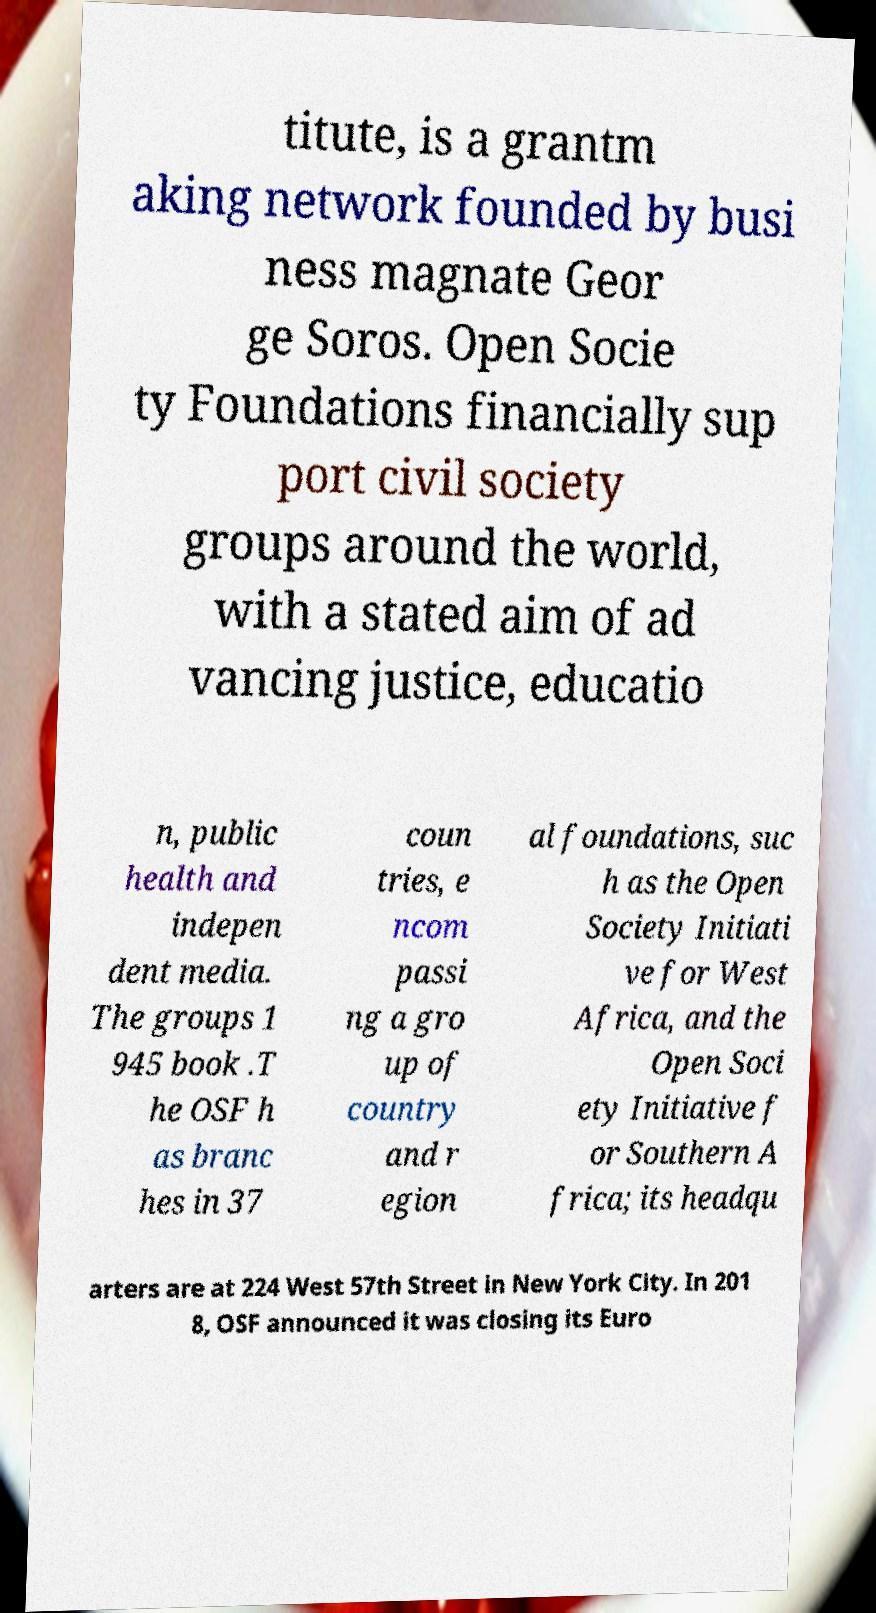There's text embedded in this image that I need extracted. Can you transcribe it verbatim? titute, is a grantm aking network founded by busi ness magnate Geor ge Soros. Open Socie ty Foundations financially sup port civil society groups around the world, with a stated aim of ad vancing justice, educatio n, public health and indepen dent media. The groups 1 945 book .T he OSF h as branc hes in 37 coun tries, e ncom passi ng a gro up of country and r egion al foundations, suc h as the Open Society Initiati ve for West Africa, and the Open Soci ety Initiative f or Southern A frica; its headqu arters are at 224 West 57th Street in New York City. In 201 8, OSF announced it was closing its Euro 